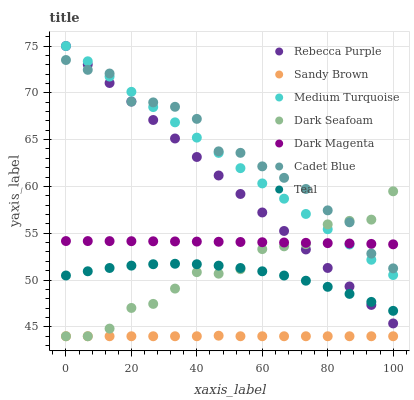Does Sandy Brown have the minimum area under the curve?
Answer yes or no. Yes. Does Cadet Blue have the maximum area under the curve?
Answer yes or no. Yes. Does Dark Magenta have the minimum area under the curve?
Answer yes or no. No. Does Dark Magenta have the maximum area under the curve?
Answer yes or no. No. Is Rebecca Purple the smoothest?
Answer yes or no. Yes. Is Cadet Blue the roughest?
Answer yes or no. Yes. Is Dark Magenta the smoothest?
Answer yes or no. No. Is Dark Magenta the roughest?
Answer yes or no. No. Does Dark Seafoam have the lowest value?
Answer yes or no. Yes. Does Cadet Blue have the lowest value?
Answer yes or no. No. Does Medium Turquoise have the highest value?
Answer yes or no. Yes. Does Cadet Blue have the highest value?
Answer yes or no. No. Is Teal less than Cadet Blue?
Answer yes or no. Yes. Is Teal greater than Sandy Brown?
Answer yes or no. Yes. Does Medium Turquoise intersect Cadet Blue?
Answer yes or no. Yes. Is Medium Turquoise less than Cadet Blue?
Answer yes or no. No. Is Medium Turquoise greater than Cadet Blue?
Answer yes or no. No. Does Teal intersect Cadet Blue?
Answer yes or no. No. 